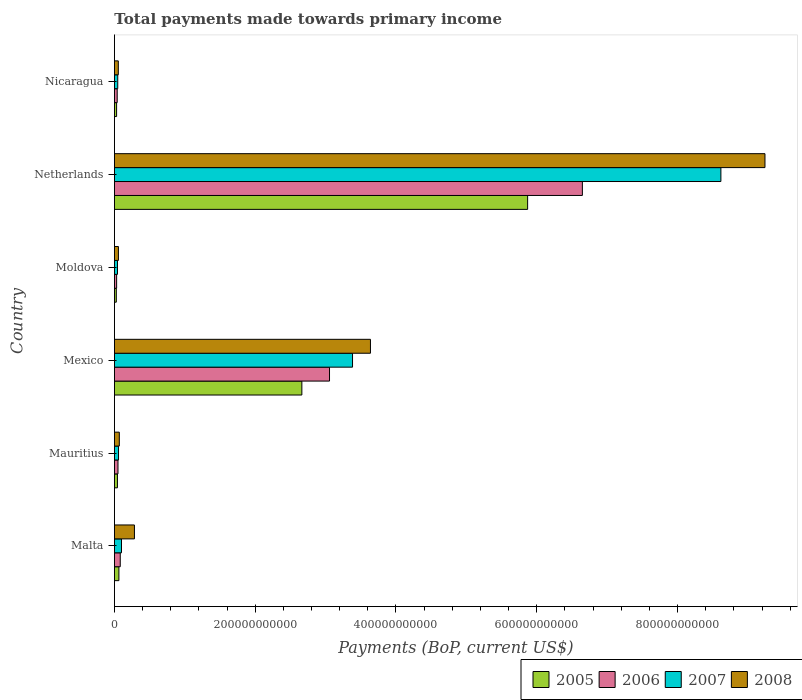How many different coloured bars are there?
Ensure brevity in your answer.  4. Are the number of bars on each tick of the Y-axis equal?
Your answer should be compact. Yes. How many bars are there on the 6th tick from the top?
Your response must be concise. 4. What is the label of the 2nd group of bars from the top?
Your answer should be very brief. Netherlands. In how many cases, is the number of bars for a given country not equal to the number of legend labels?
Offer a very short reply. 0. What is the total payments made towards primary income in 2008 in Nicaragua?
Give a very brief answer. 5.52e+09. Across all countries, what is the maximum total payments made towards primary income in 2007?
Keep it short and to the point. 8.62e+11. Across all countries, what is the minimum total payments made towards primary income in 2005?
Provide a short and direct response. 2.67e+09. In which country was the total payments made towards primary income in 2005 maximum?
Offer a terse response. Netherlands. In which country was the total payments made towards primary income in 2005 minimum?
Your answer should be very brief. Moldova. What is the total total payments made towards primary income in 2008 in the graph?
Your answer should be compact. 1.33e+12. What is the difference between the total payments made towards primary income in 2006 in Malta and that in Mexico?
Offer a very short reply. -2.97e+11. What is the difference between the total payments made towards primary income in 2008 in Moldova and the total payments made towards primary income in 2005 in Nicaragua?
Offer a terse response. 2.60e+09. What is the average total payments made towards primary income in 2006 per country?
Keep it short and to the point. 1.65e+11. What is the difference between the total payments made towards primary income in 2006 and total payments made towards primary income in 2008 in Mauritius?
Your answer should be very brief. -1.90e+09. What is the ratio of the total payments made towards primary income in 2005 in Malta to that in Netherlands?
Keep it short and to the point. 0.01. Is the total payments made towards primary income in 2008 in Mexico less than that in Moldova?
Offer a terse response. No. What is the difference between the highest and the second highest total payments made towards primary income in 2008?
Offer a terse response. 5.60e+11. What is the difference between the highest and the lowest total payments made towards primary income in 2008?
Ensure brevity in your answer.  9.19e+11. In how many countries, is the total payments made towards primary income in 2008 greater than the average total payments made towards primary income in 2008 taken over all countries?
Your response must be concise. 2. Is it the case that in every country, the sum of the total payments made towards primary income in 2006 and total payments made towards primary income in 2008 is greater than the sum of total payments made towards primary income in 2005 and total payments made towards primary income in 2007?
Make the answer very short. No. How many bars are there?
Give a very brief answer. 24. What is the difference between two consecutive major ticks on the X-axis?
Provide a succinct answer. 2.00e+11. Are the values on the major ticks of X-axis written in scientific E-notation?
Give a very brief answer. No. How are the legend labels stacked?
Offer a very short reply. Horizontal. What is the title of the graph?
Keep it short and to the point. Total payments made towards primary income. What is the label or title of the X-axis?
Give a very brief answer. Payments (BoP, current US$). What is the Payments (BoP, current US$) of 2005 in Malta?
Offer a very short reply. 6.37e+09. What is the Payments (BoP, current US$) of 2006 in Malta?
Make the answer very short. 8.26e+09. What is the Payments (BoP, current US$) in 2007 in Malta?
Give a very brief answer. 1.00e+1. What is the Payments (BoP, current US$) of 2008 in Malta?
Your response must be concise. 2.84e+1. What is the Payments (BoP, current US$) in 2005 in Mauritius?
Make the answer very short. 4.28e+09. What is the Payments (BoP, current US$) of 2006 in Mauritius?
Ensure brevity in your answer.  5.05e+09. What is the Payments (BoP, current US$) of 2007 in Mauritius?
Your answer should be compact. 5.82e+09. What is the Payments (BoP, current US$) in 2008 in Mauritius?
Your response must be concise. 6.95e+09. What is the Payments (BoP, current US$) of 2005 in Mexico?
Your answer should be very brief. 2.66e+11. What is the Payments (BoP, current US$) of 2006 in Mexico?
Your answer should be very brief. 3.06e+11. What is the Payments (BoP, current US$) in 2007 in Mexico?
Your response must be concise. 3.38e+11. What is the Payments (BoP, current US$) of 2008 in Mexico?
Your answer should be very brief. 3.64e+11. What is the Payments (BoP, current US$) of 2005 in Moldova?
Ensure brevity in your answer.  2.67e+09. What is the Payments (BoP, current US$) of 2006 in Moldova?
Offer a terse response. 3.13e+09. What is the Payments (BoP, current US$) in 2007 in Moldova?
Your response must be concise. 4.36e+09. What is the Payments (BoP, current US$) of 2008 in Moldova?
Make the answer very short. 5.67e+09. What is the Payments (BoP, current US$) in 2005 in Netherlands?
Make the answer very short. 5.87e+11. What is the Payments (BoP, current US$) in 2006 in Netherlands?
Make the answer very short. 6.65e+11. What is the Payments (BoP, current US$) of 2007 in Netherlands?
Offer a terse response. 8.62e+11. What is the Payments (BoP, current US$) of 2008 in Netherlands?
Keep it short and to the point. 9.24e+11. What is the Payments (BoP, current US$) of 2005 in Nicaragua?
Your answer should be very brief. 3.07e+09. What is the Payments (BoP, current US$) of 2006 in Nicaragua?
Ensure brevity in your answer.  3.94e+09. What is the Payments (BoP, current US$) of 2007 in Nicaragua?
Give a very brief answer. 4.71e+09. What is the Payments (BoP, current US$) in 2008 in Nicaragua?
Give a very brief answer. 5.52e+09. Across all countries, what is the maximum Payments (BoP, current US$) in 2005?
Keep it short and to the point. 5.87e+11. Across all countries, what is the maximum Payments (BoP, current US$) of 2006?
Ensure brevity in your answer.  6.65e+11. Across all countries, what is the maximum Payments (BoP, current US$) in 2007?
Ensure brevity in your answer.  8.62e+11. Across all countries, what is the maximum Payments (BoP, current US$) of 2008?
Keep it short and to the point. 9.24e+11. Across all countries, what is the minimum Payments (BoP, current US$) in 2005?
Offer a terse response. 2.67e+09. Across all countries, what is the minimum Payments (BoP, current US$) of 2006?
Offer a terse response. 3.13e+09. Across all countries, what is the minimum Payments (BoP, current US$) in 2007?
Keep it short and to the point. 4.36e+09. Across all countries, what is the minimum Payments (BoP, current US$) of 2008?
Offer a very short reply. 5.52e+09. What is the total Payments (BoP, current US$) in 2005 in the graph?
Ensure brevity in your answer.  8.70e+11. What is the total Payments (BoP, current US$) in 2006 in the graph?
Your response must be concise. 9.91e+11. What is the total Payments (BoP, current US$) of 2007 in the graph?
Offer a terse response. 1.22e+12. What is the total Payments (BoP, current US$) of 2008 in the graph?
Provide a succinct answer. 1.33e+12. What is the difference between the Payments (BoP, current US$) in 2005 in Malta and that in Mauritius?
Ensure brevity in your answer.  2.08e+09. What is the difference between the Payments (BoP, current US$) of 2006 in Malta and that in Mauritius?
Ensure brevity in your answer.  3.21e+09. What is the difference between the Payments (BoP, current US$) in 2007 in Malta and that in Mauritius?
Your answer should be compact. 4.22e+09. What is the difference between the Payments (BoP, current US$) in 2008 in Malta and that in Mauritius?
Your response must be concise. 2.15e+1. What is the difference between the Payments (BoP, current US$) of 2005 in Malta and that in Mexico?
Provide a succinct answer. -2.60e+11. What is the difference between the Payments (BoP, current US$) in 2006 in Malta and that in Mexico?
Offer a terse response. -2.97e+11. What is the difference between the Payments (BoP, current US$) in 2007 in Malta and that in Mexico?
Your answer should be compact. -3.28e+11. What is the difference between the Payments (BoP, current US$) in 2008 in Malta and that in Mexico?
Offer a terse response. -3.35e+11. What is the difference between the Payments (BoP, current US$) of 2005 in Malta and that in Moldova?
Keep it short and to the point. 3.69e+09. What is the difference between the Payments (BoP, current US$) of 2006 in Malta and that in Moldova?
Keep it short and to the point. 5.14e+09. What is the difference between the Payments (BoP, current US$) of 2007 in Malta and that in Moldova?
Provide a short and direct response. 5.68e+09. What is the difference between the Payments (BoP, current US$) of 2008 in Malta and that in Moldova?
Make the answer very short. 2.27e+1. What is the difference between the Payments (BoP, current US$) of 2005 in Malta and that in Netherlands?
Provide a succinct answer. -5.81e+11. What is the difference between the Payments (BoP, current US$) in 2006 in Malta and that in Netherlands?
Offer a very short reply. -6.57e+11. What is the difference between the Payments (BoP, current US$) in 2007 in Malta and that in Netherlands?
Give a very brief answer. -8.52e+11. What is the difference between the Payments (BoP, current US$) in 2008 in Malta and that in Netherlands?
Provide a succinct answer. -8.96e+11. What is the difference between the Payments (BoP, current US$) in 2005 in Malta and that in Nicaragua?
Give a very brief answer. 3.29e+09. What is the difference between the Payments (BoP, current US$) in 2006 in Malta and that in Nicaragua?
Keep it short and to the point. 4.32e+09. What is the difference between the Payments (BoP, current US$) in 2007 in Malta and that in Nicaragua?
Offer a very short reply. 5.33e+09. What is the difference between the Payments (BoP, current US$) of 2008 in Malta and that in Nicaragua?
Your answer should be very brief. 2.29e+1. What is the difference between the Payments (BoP, current US$) in 2005 in Mauritius and that in Mexico?
Make the answer very short. -2.62e+11. What is the difference between the Payments (BoP, current US$) of 2006 in Mauritius and that in Mexico?
Make the answer very short. -3.01e+11. What is the difference between the Payments (BoP, current US$) of 2007 in Mauritius and that in Mexico?
Offer a very short reply. -3.32e+11. What is the difference between the Payments (BoP, current US$) of 2008 in Mauritius and that in Mexico?
Give a very brief answer. -3.57e+11. What is the difference between the Payments (BoP, current US$) in 2005 in Mauritius and that in Moldova?
Your response must be concise. 1.61e+09. What is the difference between the Payments (BoP, current US$) in 2006 in Mauritius and that in Moldova?
Offer a very short reply. 1.92e+09. What is the difference between the Payments (BoP, current US$) of 2007 in Mauritius and that in Moldova?
Keep it short and to the point. 1.46e+09. What is the difference between the Payments (BoP, current US$) in 2008 in Mauritius and that in Moldova?
Your answer should be compact. 1.28e+09. What is the difference between the Payments (BoP, current US$) of 2005 in Mauritius and that in Netherlands?
Give a very brief answer. -5.83e+11. What is the difference between the Payments (BoP, current US$) of 2006 in Mauritius and that in Netherlands?
Your answer should be very brief. -6.60e+11. What is the difference between the Payments (BoP, current US$) in 2007 in Mauritius and that in Netherlands?
Keep it short and to the point. -8.56e+11. What is the difference between the Payments (BoP, current US$) of 2008 in Mauritius and that in Netherlands?
Offer a very short reply. -9.17e+11. What is the difference between the Payments (BoP, current US$) of 2005 in Mauritius and that in Nicaragua?
Your answer should be compact. 1.21e+09. What is the difference between the Payments (BoP, current US$) in 2006 in Mauritius and that in Nicaragua?
Provide a short and direct response. 1.11e+09. What is the difference between the Payments (BoP, current US$) of 2007 in Mauritius and that in Nicaragua?
Offer a very short reply. 1.11e+09. What is the difference between the Payments (BoP, current US$) in 2008 in Mauritius and that in Nicaragua?
Your response must be concise. 1.43e+09. What is the difference between the Payments (BoP, current US$) in 2005 in Mexico and that in Moldova?
Your response must be concise. 2.64e+11. What is the difference between the Payments (BoP, current US$) of 2006 in Mexico and that in Moldova?
Your answer should be very brief. 3.02e+11. What is the difference between the Payments (BoP, current US$) of 2007 in Mexico and that in Moldova?
Your answer should be compact. 3.34e+11. What is the difference between the Payments (BoP, current US$) in 2008 in Mexico and that in Moldova?
Offer a terse response. 3.58e+11. What is the difference between the Payments (BoP, current US$) in 2005 in Mexico and that in Netherlands?
Ensure brevity in your answer.  -3.21e+11. What is the difference between the Payments (BoP, current US$) of 2006 in Mexico and that in Netherlands?
Give a very brief answer. -3.59e+11. What is the difference between the Payments (BoP, current US$) of 2007 in Mexico and that in Netherlands?
Make the answer very short. -5.23e+11. What is the difference between the Payments (BoP, current US$) in 2008 in Mexico and that in Netherlands?
Keep it short and to the point. -5.60e+11. What is the difference between the Payments (BoP, current US$) of 2005 in Mexico and that in Nicaragua?
Your answer should be very brief. 2.63e+11. What is the difference between the Payments (BoP, current US$) in 2006 in Mexico and that in Nicaragua?
Your answer should be very brief. 3.02e+11. What is the difference between the Payments (BoP, current US$) of 2007 in Mexico and that in Nicaragua?
Ensure brevity in your answer.  3.34e+11. What is the difference between the Payments (BoP, current US$) in 2008 in Mexico and that in Nicaragua?
Give a very brief answer. 3.58e+11. What is the difference between the Payments (BoP, current US$) in 2005 in Moldova and that in Netherlands?
Offer a terse response. -5.84e+11. What is the difference between the Payments (BoP, current US$) of 2006 in Moldova and that in Netherlands?
Ensure brevity in your answer.  -6.62e+11. What is the difference between the Payments (BoP, current US$) of 2007 in Moldova and that in Netherlands?
Offer a terse response. -8.57e+11. What is the difference between the Payments (BoP, current US$) in 2008 in Moldova and that in Netherlands?
Your answer should be very brief. -9.19e+11. What is the difference between the Payments (BoP, current US$) of 2005 in Moldova and that in Nicaragua?
Your answer should be very brief. -4.02e+08. What is the difference between the Payments (BoP, current US$) of 2006 in Moldova and that in Nicaragua?
Provide a succinct answer. -8.14e+08. What is the difference between the Payments (BoP, current US$) in 2007 in Moldova and that in Nicaragua?
Give a very brief answer. -3.53e+08. What is the difference between the Payments (BoP, current US$) of 2008 in Moldova and that in Nicaragua?
Ensure brevity in your answer.  1.51e+08. What is the difference between the Payments (BoP, current US$) of 2005 in Netherlands and that in Nicaragua?
Ensure brevity in your answer.  5.84e+11. What is the difference between the Payments (BoP, current US$) of 2006 in Netherlands and that in Nicaragua?
Give a very brief answer. 6.61e+11. What is the difference between the Payments (BoP, current US$) in 2007 in Netherlands and that in Nicaragua?
Give a very brief answer. 8.57e+11. What is the difference between the Payments (BoP, current US$) in 2008 in Netherlands and that in Nicaragua?
Your response must be concise. 9.19e+11. What is the difference between the Payments (BoP, current US$) in 2005 in Malta and the Payments (BoP, current US$) in 2006 in Mauritius?
Provide a short and direct response. 1.32e+09. What is the difference between the Payments (BoP, current US$) of 2005 in Malta and the Payments (BoP, current US$) of 2007 in Mauritius?
Make the answer very short. 5.49e+08. What is the difference between the Payments (BoP, current US$) of 2005 in Malta and the Payments (BoP, current US$) of 2008 in Mauritius?
Provide a succinct answer. -5.81e+08. What is the difference between the Payments (BoP, current US$) in 2006 in Malta and the Payments (BoP, current US$) in 2007 in Mauritius?
Give a very brief answer. 2.45e+09. What is the difference between the Payments (BoP, current US$) of 2006 in Malta and the Payments (BoP, current US$) of 2008 in Mauritius?
Make the answer very short. 1.32e+09. What is the difference between the Payments (BoP, current US$) of 2007 in Malta and the Payments (BoP, current US$) of 2008 in Mauritius?
Offer a very short reply. 3.09e+09. What is the difference between the Payments (BoP, current US$) of 2005 in Malta and the Payments (BoP, current US$) of 2006 in Mexico?
Give a very brief answer. -2.99e+11. What is the difference between the Payments (BoP, current US$) of 2005 in Malta and the Payments (BoP, current US$) of 2007 in Mexico?
Your answer should be very brief. -3.32e+11. What is the difference between the Payments (BoP, current US$) of 2005 in Malta and the Payments (BoP, current US$) of 2008 in Mexico?
Your answer should be very brief. -3.57e+11. What is the difference between the Payments (BoP, current US$) of 2006 in Malta and the Payments (BoP, current US$) of 2007 in Mexico?
Your answer should be very brief. -3.30e+11. What is the difference between the Payments (BoP, current US$) in 2006 in Malta and the Payments (BoP, current US$) in 2008 in Mexico?
Give a very brief answer. -3.55e+11. What is the difference between the Payments (BoP, current US$) of 2007 in Malta and the Payments (BoP, current US$) of 2008 in Mexico?
Keep it short and to the point. -3.54e+11. What is the difference between the Payments (BoP, current US$) of 2005 in Malta and the Payments (BoP, current US$) of 2006 in Moldova?
Ensure brevity in your answer.  3.24e+09. What is the difference between the Payments (BoP, current US$) in 2005 in Malta and the Payments (BoP, current US$) in 2007 in Moldova?
Provide a succinct answer. 2.01e+09. What is the difference between the Payments (BoP, current US$) in 2005 in Malta and the Payments (BoP, current US$) in 2008 in Moldova?
Give a very brief answer. 6.97e+08. What is the difference between the Payments (BoP, current US$) of 2006 in Malta and the Payments (BoP, current US$) of 2007 in Moldova?
Offer a terse response. 3.91e+09. What is the difference between the Payments (BoP, current US$) of 2006 in Malta and the Payments (BoP, current US$) of 2008 in Moldova?
Keep it short and to the point. 2.59e+09. What is the difference between the Payments (BoP, current US$) in 2007 in Malta and the Payments (BoP, current US$) in 2008 in Moldova?
Provide a short and direct response. 4.37e+09. What is the difference between the Payments (BoP, current US$) in 2005 in Malta and the Payments (BoP, current US$) in 2006 in Netherlands?
Your answer should be compact. -6.58e+11. What is the difference between the Payments (BoP, current US$) of 2005 in Malta and the Payments (BoP, current US$) of 2007 in Netherlands?
Provide a succinct answer. -8.55e+11. What is the difference between the Payments (BoP, current US$) in 2005 in Malta and the Payments (BoP, current US$) in 2008 in Netherlands?
Offer a very short reply. -9.18e+11. What is the difference between the Payments (BoP, current US$) of 2006 in Malta and the Payments (BoP, current US$) of 2007 in Netherlands?
Your answer should be very brief. -8.53e+11. What is the difference between the Payments (BoP, current US$) of 2006 in Malta and the Payments (BoP, current US$) of 2008 in Netherlands?
Ensure brevity in your answer.  -9.16e+11. What is the difference between the Payments (BoP, current US$) in 2007 in Malta and the Payments (BoP, current US$) in 2008 in Netherlands?
Your answer should be very brief. -9.14e+11. What is the difference between the Payments (BoP, current US$) in 2005 in Malta and the Payments (BoP, current US$) in 2006 in Nicaragua?
Provide a short and direct response. 2.42e+09. What is the difference between the Payments (BoP, current US$) of 2005 in Malta and the Payments (BoP, current US$) of 2007 in Nicaragua?
Offer a terse response. 1.65e+09. What is the difference between the Payments (BoP, current US$) of 2005 in Malta and the Payments (BoP, current US$) of 2008 in Nicaragua?
Offer a very short reply. 8.48e+08. What is the difference between the Payments (BoP, current US$) in 2006 in Malta and the Payments (BoP, current US$) in 2007 in Nicaragua?
Provide a succinct answer. 3.55e+09. What is the difference between the Payments (BoP, current US$) of 2006 in Malta and the Payments (BoP, current US$) of 2008 in Nicaragua?
Make the answer very short. 2.74e+09. What is the difference between the Payments (BoP, current US$) in 2007 in Malta and the Payments (BoP, current US$) in 2008 in Nicaragua?
Your answer should be compact. 4.52e+09. What is the difference between the Payments (BoP, current US$) of 2005 in Mauritius and the Payments (BoP, current US$) of 2006 in Mexico?
Your response must be concise. -3.01e+11. What is the difference between the Payments (BoP, current US$) in 2005 in Mauritius and the Payments (BoP, current US$) in 2007 in Mexico?
Offer a terse response. -3.34e+11. What is the difference between the Payments (BoP, current US$) of 2005 in Mauritius and the Payments (BoP, current US$) of 2008 in Mexico?
Offer a terse response. -3.59e+11. What is the difference between the Payments (BoP, current US$) of 2006 in Mauritius and the Payments (BoP, current US$) of 2007 in Mexico?
Keep it short and to the point. -3.33e+11. What is the difference between the Payments (BoP, current US$) of 2006 in Mauritius and the Payments (BoP, current US$) of 2008 in Mexico?
Provide a succinct answer. -3.59e+11. What is the difference between the Payments (BoP, current US$) of 2007 in Mauritius and the Payments (BoP, current US$) of 2008 in Mexico?
Ensure brevity in your answer.  -3.58e+11. What is the difference between the Payments (BoP, current US$) of 2005 in Mauritius and the Payments (BoP, current US$) of 2006 in Moldova?
Your answer should be compact. 1.16e+09. What is the difference between the Payments (BoP, current US$) of 2005 in Mauritius and the Payments (BoP, current US$) of 2007 in Moldova?
Your response must be concise. -7.46e+07. What is the difference between the Payments (BoP, current US$) in 2005 in Mauritius and the Payments (BoP, current US$) in 2008 in Moldova?
Give a very brief answer. -1.39e+09. What is the difference between the Payments (BoP, current US$) in 2006 in Mauritius and the Payments (BoP, current US$) in 2007 in Moldova?
Keep it short and to the point. 6.91e+08. What is the difference between the Payments (BoP, current US$) in 2006 in Mauritius and the Payments (BoP, current US$) in 2008 in Moldova?
Provide a short and direct response. -6.21e+08. What is the difference between the Payments (BoP, current US$) in 2007 in Mauritius and the Payments (BoP, current US$) in 2008 in Moldova?
Your answer should be compact. 1.48e+08. What is the difference between the Payments (BoP, current US$) in 2005 in Mauritius and the Payments (BoP, current US$) in 2006 in Netherlands?
Your response must be concise. -6.61e+11. What is the difference between the Payments (BoP, current US$) of 2005 in Mauritius and the Payments (BoP, current US$) of 2007 in Netherlands?
Keep it short and to the point. -8.57e+11. What is the difference between the Payments (BoP, current US$) in 2005 in Mauritius and the Payments (BoP, current US$) in 2008 in Netherlands?
Your response must be concise. -9.20e+11. What is the difference between the Payments (BoP, current US$) of 2006 in Mauritius and the Payments (BoP, current US$) of 2007 in Netherlands?
Offer a very short reply. -8.57e+11. What is the difference between the Payments (BoP, current US$) in 2006 in Mauritius and the Payments (BoP, current US$) in 2008 in Netherlands?
Your answer should be compact. -9.19e+11. What is the difference between the Payments (BoP, current US$) in 2007 in Mauritius and the Payments (BoP, current US$) in 2008 in Netherlands?
Offer a terse response. -9.18e+11. What is the difference between the Payments (BoP, current US$) in 2005 in Mauritius and the Payments (BoP, current US$) in 2006 in Nicaragua?
Provide a short and direct response. 3.42e+08. What is the difference between the Payments (BoP, current US$) in 2005 in Mauritius and the Payments (BoP, current US$) in 2007 in Nicaragua?
Make the answer very short. -4.28e+08. What is the difference between the Payments (BoP, current US$) in 2005 in Mauritius and the Payments (BoP, current US$) in 2008 in Nicaragua?
Ensure brevity in your answer.  -1.23e+09. What is the difference between the Payments (BoP, current US$) of 2006 in Mauritius and the Payments (BoP, current US$) of 2007 in Nicaragua?
Ensure brevity in your answer.  3.37e+08. What is the difference between the Payments (BoP, current US$) of 2006 in Mauritius and the Payments (BoP, current US$) of 2008 in Nicaragua?
Ensure brevity in your answer.  -4.70e+08. What is the difference between the Payments (BoP, current US$) of 2007 in Mauritius and the Payments (BoP, current US$) of 2008 in Nicaragua?
Your response must be concise. 2.99e+08. What is the difference between the Payments (BoP, current US$) in 2005 in Mexico and the Payments (BoP, current US$) in 2006 in Moldova?
Offer a terse response. 2.63e+11. What is the difference between the Payments (BoP, current US$) in 2005 in Mexico and the Payments (BoP, current US$) in 2007 in Moldova?
Give a very brief answer. 2.62e+11. What is the difference between the Payments (BoP, current US$) of 2005 in Mexico and the Payments (BoP, current US$) of 2008 in Moldova?
Make the answer very short. 2.61e+11. What is the difference between the Payments (BoP, current US$) of 2006 in Mexico and the Payments (BoP, current US$) of 2007 in Moldova?
Your answer should be very brief. 3.01e+11. What is the difference between the Payments (BoP, current US$) in 2006 in Mexico and the Payments (BoP, current US$) in 2008 in Moldova?
Ensure brevity in your answer.  3.00e+11. What is the difference between the Payments (BoP, current US$) of 2007 in Mexico and the Payments (BoP, current US$) of 2008 in Moldova?
Ensure brevity in your answer.  3.33e+11. What is the difference between the Payments (BoP, current US$) of 2005 in Mexico and the Payments (BoP, current US$) of 2006 in Netherlands?
Your answer should be compact. -3.99e+11. What is the difference between the Payments (BoP, current US$) in 2005 in Mexico and the Payments (BoP, current US$) in 2007 in Netherlands?
Keep it short and to the point. -5.95e+11. What is the difference between the Payments (BoP, current US$) in 2005 in Mexico and the Payments (BoP, current US$) in 2008 in Netherlands?
Offer a terse response. -6.58e+11. What is the difference between the Payments (BoP, current US$) in 2006 in Mexico and the Payments (BoP, current US$) in 2007 in Netherlands?
Your answer should be compact. -5.56e+11. What is the difference between the Payments (BoP, current US$) of 2006 in Mexico and the Payments (BoP, current US$) of 2008 in Netherlands?
Give a very brief answer. -6.19e+11. What is the difference between the Payments (BoP, current US$) of 2007 in Mexico and the Payments (BoP, current US$) of 2008 in Netherlands?
Offer a very short reply. -5.86e+11. What is the difference between the Payments (BoP, current US$) in 2005 in Mexico and the Payments (BoP, current US$) in 2006 in Nicaragua?
Provide a short and direct response. 2.62e+11. What is the difference between the Payments (BoP, current US$) of 2005 in Mexico and the Payments (BoP, current US$) of 2007 in Nicaragua?
Keep it short and to the point. 2.62e+11. What is the difference between the Payments (BoP, current US$) of 2005 in Mexico and the Payments (BoP, current US$) of 2008 in Nicaragua?
Your response must be concise. 2.61e+11. What is the difference between the Payments (BoP, current US$) in 2006 in Mexico and the Payments (BoP, current US$) in 2007 in Nicaragua?
Provide a succinct answer. 3.01e+11. What is the difference between the Payments (BoP, current US$) of 2006 in Mexico and the Payments (BoP, current US$) of 2008 in Nicaragua?
Offer a terse response. 3.00e+11. What is the difference between the Payments (BoP, current US$) in 2007 in Mexico and the Payments (BoP, current US$) in 2008 in Nicaragua?
Offer a terse response. 3.33e+11. What is the difference between the Payments (BoP, current US$) in 2005 in Moldova and the Payments (BoP, current US$) in 2006 in Netherlands?
Provide a succinct answer. -6.62e+11. What is the difference between the Payments (BoP, current US$) of 2005 in Moldova and the Payments (BoP, current US$) of 2007 in Netherlands?
Provide a succinct answer. -8.59e+11. What is the difference between the Payments (BoP, current US$) in 2005 in Moldova and the Payments (BoP, current US$) in 2008 in Netherlands?
Offer a terse response. -9.22e+11. What is the difference between the Payments (BoP, current US$) in 2006 in Moldova and the Payments (BoP, current US$) in 2007 in Netherlands?
Make the answer very short. -8.58e+11. What is the difference between the Payments (BoP, current US$) in 2006 in Moldova and the Payments (BoP, current US$) in 2008 in Netherlands?
Make the answer very short. -9.21e+11. What is the difference between the Payments (BoP, current US$) of 2007 in Moldova and the Payments (BoP, current US$) of 2008 in Netherlands?
Your answer should be compact. -9.20e+11. What is the difference between the Payments (BoP, current US$) in 2005 in Moldova and the Payments (BoP, current US$) in 2006 in Nicaragua?
Offer a very short reply. -1.27e+09. What is the difference between the Payments (BoP, current US$) in 2005 in Moldova and the Payments (BoP, current US$) in 2007 in Nicaragua?
Provide a short and direct response. -2.04e+09. What is the difference between the Payments (BoP, current US$) of 2005 in Moldova and the Payments (BoP, current US$) of 2008 in Nicaragua?
Your answer should be compact. -2.85e+09. What is the difference between the Payments (BoP, current US$) of 2006 in Moldova and the Payments (BoP, current US$) of 2007 in Nicaragua?
Offer a terse response. -1.58e+09. What is the difference between the Payments (BoP, current US$) of 2006 in Moldova and the Payments (BoP, current US$) of 2008 in Nicaragua?
Offer a terse response. -2.39e+09. What is the difference between the Payments (BoP, current US$) of 2007 in Moldova and the Payments (BoP, current US$) of 2008 in Nicaragua?
Make the answer very short. -1.16e+09. What is the difference between the Payments (BoP, current US$) in 2005 in Netherlands and the Payments (BoP, current US$) in 2006 in Nicaragua?
Keep it short and to the point. 5.83e+11. What is the difference between the Payments (BoP, current US$) in 2005 in Netherlands and the Payments (BoP, current US$) in 2007 in Nicaragua?
Your answer should be very brief. 5.82e+11. What is the difference between the Payments (BoP, current US$) of 2005 in Netherlands and the Payments (BoP, current US$) of 2008 in Nicaragua?
Your response must be concise. 5.82e+11. What is the difference between the Payments (BoP, current US$) in 2006 in Netherlands and the Payments (BoP, current US$) in 2007 in Nicaragua?
Keep it short and to the point. 6.60e+11. What is the difference between the Payments (BoP, current US$) in 2006 in Netherlands and the Payments (BoP, current US$) in 2008 in Nicaragua?
Offer a very short reply. 6.59e+11. What is the difference between the Payments (BoP, current US$) in 2007 in Netherlands and the Payments (BoP, current US$) in 2008 in Nicaragua?
Your answer should be very brief. 8.56e+11. What is the average Payments (BoP, current US$) in 2005 per country?
Offer a very short reply. 1.45e+11. What is the average Payments (BoP, current US$) in 2006 per country?
Ensure brevity in your answer.  1.65e+11. What is the average Payments (BoP, current US$) of 2007 per country?
Keep it short and to the point. 2.04e+11. What is the average Payments (BoP, current US$) in 2008 per country?
Your answer should be compact. 2.22e+11. What is the difference between the Payments (BoP, current US$) in 2005 and Payments (BoP, current US$) in 2006 in Malta?
Give a very brief answer. -1.90e+09. What is the difference between the Payments (BoP, current US$) of 2005 and Payments (BoP, current US$) of 2007 in Malta?
Offer a terse response. -3.67e+09. What is the difference between the Payments (BoP, current US$) of 2005 and Payments (BoP, current US$) of 2008 in Malta?
Offer a terse response. -2.21e+1. What is the difference between the Payments (BoP, current US$) of 2006 and Payments (BoP, current US$) of 2007 in Malta?
Give a very brief answer. -1.78e+09. What is the difference between the Payments (BoP, current US$) in 2006 and Payments (BoP, current US$) in 2008 in Malta?
Your answer should be compact. -2.02e+1. What is the difference between the Payments (BoP, current US$) of 2007 and Payments (BoP, current US$) of 2008 in Malta?
Your answer should be very brief. -1.84e+1. What is the difference between the Payments (BoP, current US$) of 2005 and Payments (BoP, current US$) of 2006 in Mauritius?
Provide a short and direct response. -7.65e+08. What is the difference between the Payments (BoP, current US$) in 2005 and Payments (BoP, current US$) in 2007 in Mauritius?
Provide a short and direct response. -1.53e+09. What is the difference between the Payments (BoP, current US$) in 2005 and Payments (BoP, current US$) in 2008 in Mauritius?
Your answer should be compact. -2.66e+09. What is the difference between the Payments (BoP, current US$) of 2006 and Payments (BoP, current US$) of 2007 in Mauritius?
Your answer should be very brief. -7.69e+08. What is the difference between the Payments (BoP, current US$) in 2006 and Payments (BoP, current US$) in 2008 in Mauritius?
Provide a succinct answer. -1.90e+09. What is the difference between the Payments (BoP, current US$) in 2007 and Payments (BoP, current US$) in 2008 in Mauritius?
Provide a short and direct response. -1.13e+09. What is the difference between the Payments (BoP, current US$) of 2005 and Payments (BoP, current US$) of 2006 in Mexico?
Your response must be concise. -3.93e+1. What is the difference between the Payments (BoP, current US$) of 2005 and Payments (BoP, current US$) of 2007 in Mexico?
Make the answer very short. -7.20e+1. What is the difference between the Payments (BoP, current US$) in 2005 and Payments (BoP, current US$) in 2008 in Mexico?
Your answer should be compact. -9.74e+1. What is the difference between the Payments (BoP, current US$) of 2006 and Payments (BoP, current US$) of 2007 in Mexico?
Make the answer very short. -3.27e+1. What is the difference between the Payments (BoP, current US$) in 2006 and Payments (BoP, current US$) in 2008 in Mexico?
Offer a very short reply. -5.82e+1. What is the difference between the Payments (BoP, current US$) in 2007 and Payments (BoP, current US$) in 2008 in Mexico?
Provide a short and direct response. -2.55e+1. What is the difference between the Payments (BoP, current US$) of 2005 and Payments (BoP, current US$) of 2006 in Moldova?
Your answer should be very brief. -4.56e+08. What is the difference between the Payments (BoP, current US$) in 2005 and Payments (BoP, current US$) in 2007 in Moldova?
Make the answer very short. -1.69e+09. What is the difference between the Payments (BoP, current US$) in 2005 and Payments (BoP, current US$) in 2008 in Moldova?
Your answer should be compact. -3.00e+09. What is the difference between the Payments (BoP, current US$) in 2006 and Payments (BoP, current US$) in 2007 in Moldova?
Offer a terse response. -1.23e+09. What is the difference between the Payments (BoP, current US$) of 2006 and Payments (BoP, current US$) of 2008 in Moldova?
Your response must be concise. -2.54e+09. What is the difference between the Payments (BoP, current US$) of 2007 and Payments (BoP, current US$) of 2008 in Moldova?
Offer a terse response. -1.31e+09. What is the difference between the Payments (BoP, current US$) of 2005 and Payments (BoP, current US$) of 2006 in Netherlands?
Offer a very short reply. -7.78e+1. What is the difference between the Payments (BoP, current US$) of 2005 and Payments (BoP, current US$) of 2007 in Netherlands?
Your answer should be very brief. -2.75e+11. What is the difference between the Payments (BoP, current US$) in 2005 and Payments (BoP, current US$) in 2008 in Netherlands?
Provide a succinct answer. -3.37e+11. What is the difference between the Payments (BoP, current US$) in 2006 and Payments (BoP, current US$) in 2007 in Netherlands?
Provide a succinct answer. -1.97e+11. What is the difference between the Payments (BoP, current US$) in 2006 and Payments (BoP, current US$) in 2008 in Netherlands?
Give a very brief answer. -2.59e+11. What is the difference between the Payments (BoP, current US$) of 2007 and Payments (BoP, current US$) of 2008 in Netherlands?
Your answer should be very brief. -6.26e+1. What is the difference between the Payments (BoP, current US$) of 2005 and Payments (BoP, current US$) of 2006 in Nicaragua?
Ensure brevity in your answer.  -8.67e+08. What is the difference between the Payments (BoP, current US$) in 2005 and Payments (BoP, current US$) in 2007 in Nicaragua?
Your answer should be very brief. -1.64e+09. What is the difference between the Payments (BoP, current US$) in 2005 and Payments (BoP, current US$) in 2008 in Nicaragua?
Offer a terse response. -2.44e+09. What is the difference between the Payments (BoP, current US$) of 2006 and Payments (BoP, current US$) of 2007 in Nicaragua?
Ensure brevity in your answer.  -7.70e+08. What is the difference between the Payments (BoP, current US$) in 2006 and Payments (BoP, current US$) in 2008 in Nicaragua?
Provide a short and direct response. -1.58e+09. What is the difference between the Payments (BoP, current US$) of 2007 and Payments (BoP, current US$) of 2008 in Nicaragua?
Your answer should be very brief. -8.07e+08. What is the ratio of the Payments (BoP, current US$) in 2005 in Malta to that in Mauritius?
Keep it short and to the point. 1.49. What is the ratio of the Payments (BoP, current US$) of 2006 in Malta to that in Mauritius?
Provide a short and direct response. 1.64. What is the ratio of the Payments (BoP, current US$) in 2007 in Malta to that in Mauritius?
Provide a succinct answer. 1.73. What is the ratio of the Payments (BoP, current US$) in 2008 in Malta to that in Mauritius?
Offer a very short reply. 4.09. What is the ratio of the Payments (BoP, current US$) in 2005 in Malta to that in Mexico?
Provide a short and direct response. 0.02. What is the ratio of the Payments (BoP, current US$) of 2006 in Malta to that in Mexico?
Keep it short and to the point. 0.03. What is the ratio of the Payments (BoP, current US$) of 2007 in Malta to that in Mexico?
Your response must be concise. 0.03. What is the ratio of the Payments (BoP, current US$) of 2008 in Malta to that in Mexico?
Make the answer very short. 0.08. What is the ratio of the Payments (BoP, current US$) in 2005 in Malta to that in Moldova?
Provide a short and direct response. 2.38. What is the ratio of the Payments (BoP, current US$) of 2006 in Malta to that in Moldova?
Make the answer very short. 2.64. What is the ratio of the Payments (BoP, current US$) of 2007 in Malta to that in Moldova?
Your answer should be very brief. 2.3. What is the ratio of the Payments (BoP, current US$) of 2008 in Malta to that in Moldova?
Give a very brief answer. 5.01. What is the ratio of the Payments (BoP, current US$) of 2005 in Malta to that in Netherlands?
Offer a terse response. 0.01. What is the ratio of the Payments (BoP, current US$) in 2006 in Malta to that in Netherlands?
Offer a very short reply. 0.01. What is the ratio of the Payments (BoP, current US$) in 2007 in Malta to that in Netherlands?
Your answer should be compact. 0.01. What is the ratio of the Payments (BoP, current US$) of 2008 in Malta to that in Netherlands?
Your answer should be compact. 0.03. What is the ratio of the Payments (BoP, current US$) of 2005 in Malta to that in Nicaragua?
Offer a terse response. 2.07. What is the ratio of the Payments (BoP, current US$) of 2006 in Malta to that in Nicaragua?
Provide a short and direct response. 2.1. What is the ratio of the Payments (BoP, current US$) in 2007 in Malta to that in Nicaragua?
Your answer should be compact. 2.13. What is the ratio of the Payments (BoP, current US$) in 2008 in Malta to that in Nicaragua?
Provide a succinct answer. 5.15. What is the ratio of the Payments (BoP, current US$) in 2005 in Mauritius to that in Mexico?
Make the answer very short. 0.02. What is the ratio of the Payments (BoP, current US$) in 2006 in Mauritius to that in Mexico?
Provide a short and direct response. 0.02. What is the ratio of the Payments (BoP, current US$) in 2007 in Mauritius to that in Mexico?
Provide a succinct answer. 0.02. What is the ratio of the Payments (BoP, current US$) of 2008 in Mauritius to that in Mexico?
Your answer should be compact. 0.02. What is the ratio of the Payments (BoP, current US$) in 2005 in Mauritius to that in Moldova?
Make the answer very short. 1.6. What is the ratio of the Payments (BoP, current US$) of 2006 in Mauritius to that in Moldova?
Provide a short and direct response. 1.61. What is the ratio of the Payments (BoP, current US$) in 2007 in Mauritius to that in Moldova?
Provide a short and direct response. 1.33. What is the ratio of the Payments (BoP, current US$) in 2008 in Mauritius to that in Moldova?
Make the answer very short. 1.23. What is the ratio of the Payments (BoP, current US$) of 2005 in Mauritius to that in Netherlands?
Give a very brief answer. 0.01. What is the ratio of the Payments (BoP, current US$) in 2006 in Mauritius to that in Netherlands?
Your answer should be compact. 0.01. What is the ratio of the Payments (BoP, current US$) in 2007 in Mauritius to that in Netherlands?
Make the answer very short. 0.01. What is the ratio of the Payments (BoP, current US$) in 2008 in Mauritius to that in Netherlands?
Provide a succinct answer. 0.01. What is the ratio of the Payments (BoP, current US$) in 2005 in Mauritius to that in Nicaragua?
Your response must be concise. 1.39. What is the ratio of the Payments (BoP, current US$) of 2006 in Mauritius to that in Nicaragua?
Provide a short and direct response. 1.28. What is the ratio of the Payments (BoP, current US$) in 2007 in Mauritius to that in Nicaragua?
Give a very brief answer. 1.23. What is the ratio of the Payments (BoP, current US$) in 2008 in Mauritius to that in Nicaragua?
Your answer should be very brief. 1.26. What is the ratio of the Payments (BoP, current US$) of 2005 in Mexico to that in Moldova?
Your answer should be very brief. 99.62. What is the ratio of the Payments (BoP, current US$) in 2006 in Mexico to that in Moldova?
Ensure brevity in your answer.  97.66. What is the ratio of the Payments (BoP, current US$) in 2007 in Mexico to that in Moldova?
Provide a short and direct response. 77.6. What is the ratio of the Payments (BoP, current US$) in 2008 in Mexico to that in Moldova?
Give a very brief answer. 64.15. What is the ratio of the Payments (BoP, current US$) in 2005 in Mexico to that in Netherlands?
Give a very brief answer. 0.45. What is the ratio of the Payments (BoP, current US$) of 2006 in Mexico to that in Netherlands?
Offer a very short reply. 0.46. What is the ratio of the Payments (BoP, current US$) in 2007 in Mexico to that in Netherlands?
Your answer should be compact. 0.39. What is the ratio of the Payments (BoP, current US$) of 2008 in Mexico to that in Netherlands?
Ensure brevity in your answer.  0.39. What is the ratio of the Payments (BoP, current US$) of 2005 in Mexico to that in Nicaragua?
Provide a succinct answer. 86.6. What is the ratio of the Payments (BoP, current US$) in 2006 in Mexico to that in Nicaragua?
Provide a short and direct response. 77.51. What is the ratio of the Payments (BoP, current US$) of 2007 in Mexico to that in Nicaragua?
Make the answer very short. 71.79. What is the ratio of the Payments (BoP, current US$) in 2008 in Mexico to that in Nicaragua?
Ensure brevity in your answer.  65.9. What is the ratio of the Payments (BoP, current US$) of 2005 in Moldova to that in Netherlands?
Make the answer very short. 0. What is the ratio of the Payments (BoP, current US$) in 2006 in Moldova to that in Netherlands?
Give a very brief answer. 0. What is the ratio of the Payments (BoP, current US$) of 2007 in Moldova to that in Netherlands?
Your response must be concise. 0.01. What is the ratio of the Payments (BoP, current US$) in 2008 in Moldova to that in Netherlands?
Keep it short and to the point. 0.01. What is the ratio of the Payments (BoP, current US$) of 2005 in Moldova to that in Nicaragua?
Give a very brief answer. 0.87. What is the ratio of the Payments (BoP, current US$) of 2006 in Moldova to that in Nicaragua?
Provide a short and direct response. 0.79. What is the ratio of the Payments (BoP, current US$) in 2007 in Moldova to that in Nicaragua?
Provide a succinct answer. 0.93. What is the ratio of the Payments (BoP, current US$) in 2008 in Moldova to that in Nicaragua?
Your answer should be very brief. 1.03. What is the ratio of the Payments (BoP, current US$) in 2005 in Netherlands to that in Nicaragua?
Offer a terse response. 190.91. What is the ratio of the Payments (BoP, current US$) in 2006 in Netherlands to that in Nicaragua?
Offer a terse response. 168.63. What is the ratio of the Payments (BoP, current US$) of 2007 in Netherlands to that in Nicaragua?
Offer a terse response. 182.84. What is the ratio of the Payments (BoP, current US$) in 2008 in Netherlands to that in Nicaragua?
Provide a short and direct response. 167.45. What is the difference between the highest and the second highest Payments (BoP, current US$) in 2005?
Offer a terse response. 3.21e+11. What is the difference between the highest and the second highest Payments (BoP, current US$) of 2006?
Make the answer very short. 3.59e+11. What is the difference between the highest and the second highest Payments (BoP, current US$) in 2007?
Give a very brief answer. 5.23e+11. What is the difference between the highest and the second highest Payments (BoP, current US$) of 2008?
Provide a short and direct response. 5.60e+11. What is the difference between the highest and the lowest Payments (BoP, current US$) in 2005?
Provide a succinct answer. 5.84e+11. What is the difference between the highest and the lowest Payments (BoP, current US$) in 2006?
Your answer should be compact. 6.62e+11. What is the difference between the highest and the lowest Payments (BoP, current US$) in 2007?
Offer a very short reply. 8.57e+11. What is the difference between the highest and the lowest Payments (BoP, current US$) in 2008?
Your response must be concise. 9.19e+11. 